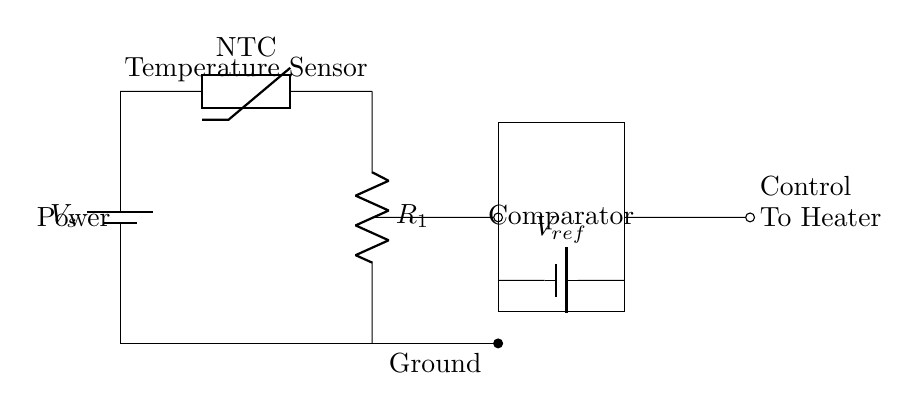What type of thermistor is used in this circuit? The circuit diagram indicates that an NTC thermistor is present, which is labeled as such. NTC stands for Negative Temperature Coefficient, meaning its resistance decreases as the temperature rises.
Answer: NTC What is the function of the comparator in this circuit? The comparator compares the voltage from the thermistor (which varies with temperature) to a reference voltage. Based on this comparison, it decides whether to activate the heater.
Answer: Control heating What is the output of this circuit connected to? The output of the circuit is indicated to be connected to "To Heater," which shows that the circuit is meant to control a heating element based on temperature feedback.
Answer: To Heater What is the reference voltage labeled as? The reference voltage in the circuit is labeled as "V ref." This voltage is used for the comparison with the thermistor's voltage.
Answer: V ref How many main components are used in this circuit? The main components include a battery, a thermistor, a resistor, a comparator, and another battery for reference voltage, totaling five distinct components.
Answer: Five components What will happen if the thermistor temperature decreases? If the temperature decreases, the resistance of the NTC thermistor will increase, leading to a lower voltage at the comparator input. If this voltage is lower than the reference voltage, the comparator's output will signal to turn on the heater.
Answer: Heater turns on What does the battery labeled "V s" represent? The battery labeled "V s" represents the main power supply for the circuit, providing the necessary voltage to operate the components.
Answer: Main power supply 